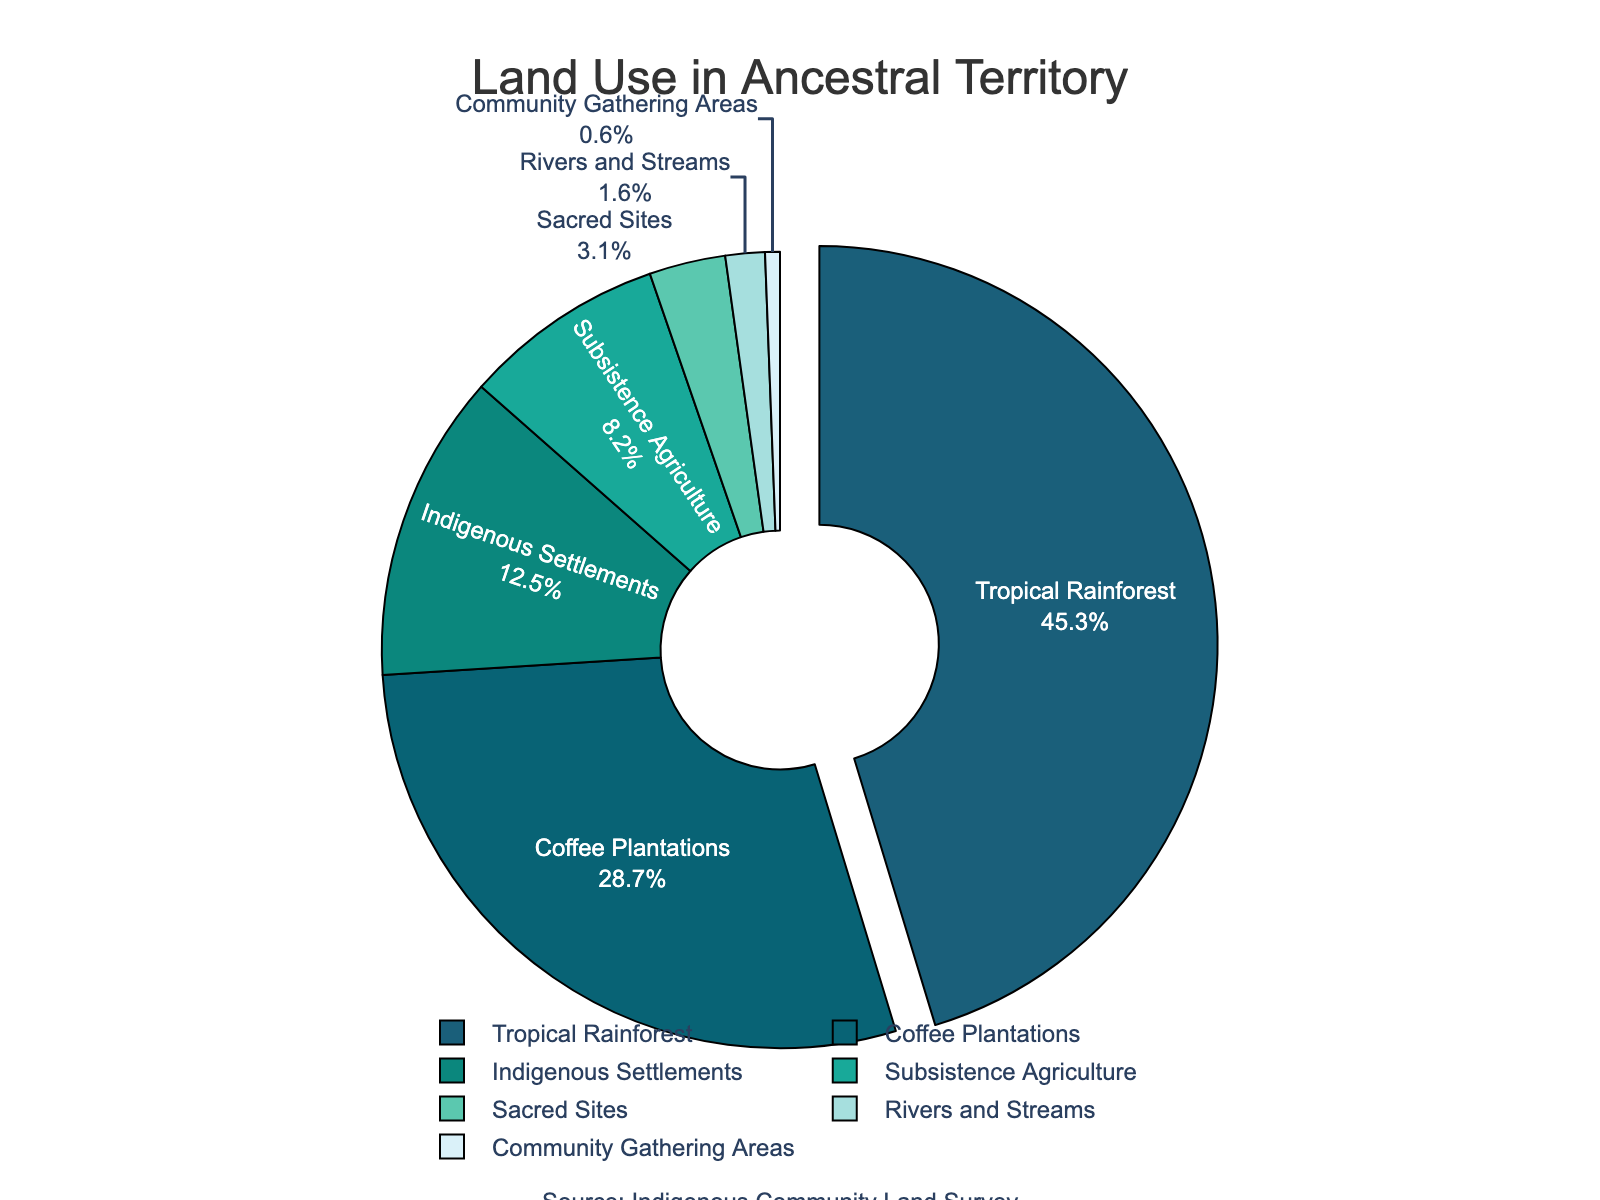What is the largest category of land use in the ancestral territory? The largest segment in the pie chart corresponds to the "Tropical Rainforest", accounting for 45.3% of the land use.
Answer: Tropical Rainforest How much more land is used for coffee plantations compared to subsistence agriculture? The land used for coffee plantations is 28.7%, and for subsistence agriculture, it is 8.2%. The difference is calculated as 28.7 - 8.2 = 20.5%.
Answer: 20.5% What percentage of the land is utilized for indigenous settlements and sacred sites together? The percentage of the land used for indigenous settlements is 12.5%, and for sacred sites, it is 3.1%. Adding these together gives 12.5 + 3.1 = 15.6%.
Answer: 15.6% Is the percentage of land used for rivers and streams greater than that for community gathering areas? The percentage of land used for rivers and streams is 1.6%, whereas for community gathering areas, it is 0.6%. Since 1.6% is greater than 0.6%, the answer is yes.
Answer: Yes What segment is visually highlighted by being pulled out from the pie chart? The segment that is visually highlighted by being pulled out from the pie chart is "Tropical Rainforest," indicating it is a significant category.
Answer: Tropical Rainforest If we combine the land used for both agriculture-related activities (coffee plantations and subsistence agriculture), what is the total percentage of land used? The percentage of land used for coffee plantations is 28.7%, and for subsistence agriculture, it is 8.2%. Adding these together gives 28.7 + 8.2 = 36.9%.
Answer: 36.9% What color represents sacred sites in the pie chart? The segment representing sacred sites is colored light green in the pie chart.
Answer: Light Green Compare the land use of tropical rainforest and coffee plantations. Which one occupies a larger area and by how much? The land use for tropical rainforest is 45.3%, while for coffee plantations, it is 28.7%. The difference is calculated as 45.3 - 28.7 = 16.6%, so the tropical rainforest occupies a larger area by 16.6%.
Answer: 16.6% What is the average percentage of land use for rivers and streams and community gathering areas? The percentage of land use for rivers and streams is 1.6%, and for community gathering areas, it is 0.6%. The average is calculated as (1.6 + 0.6) / 2 = 1.1%.
Answer: 1.1% 